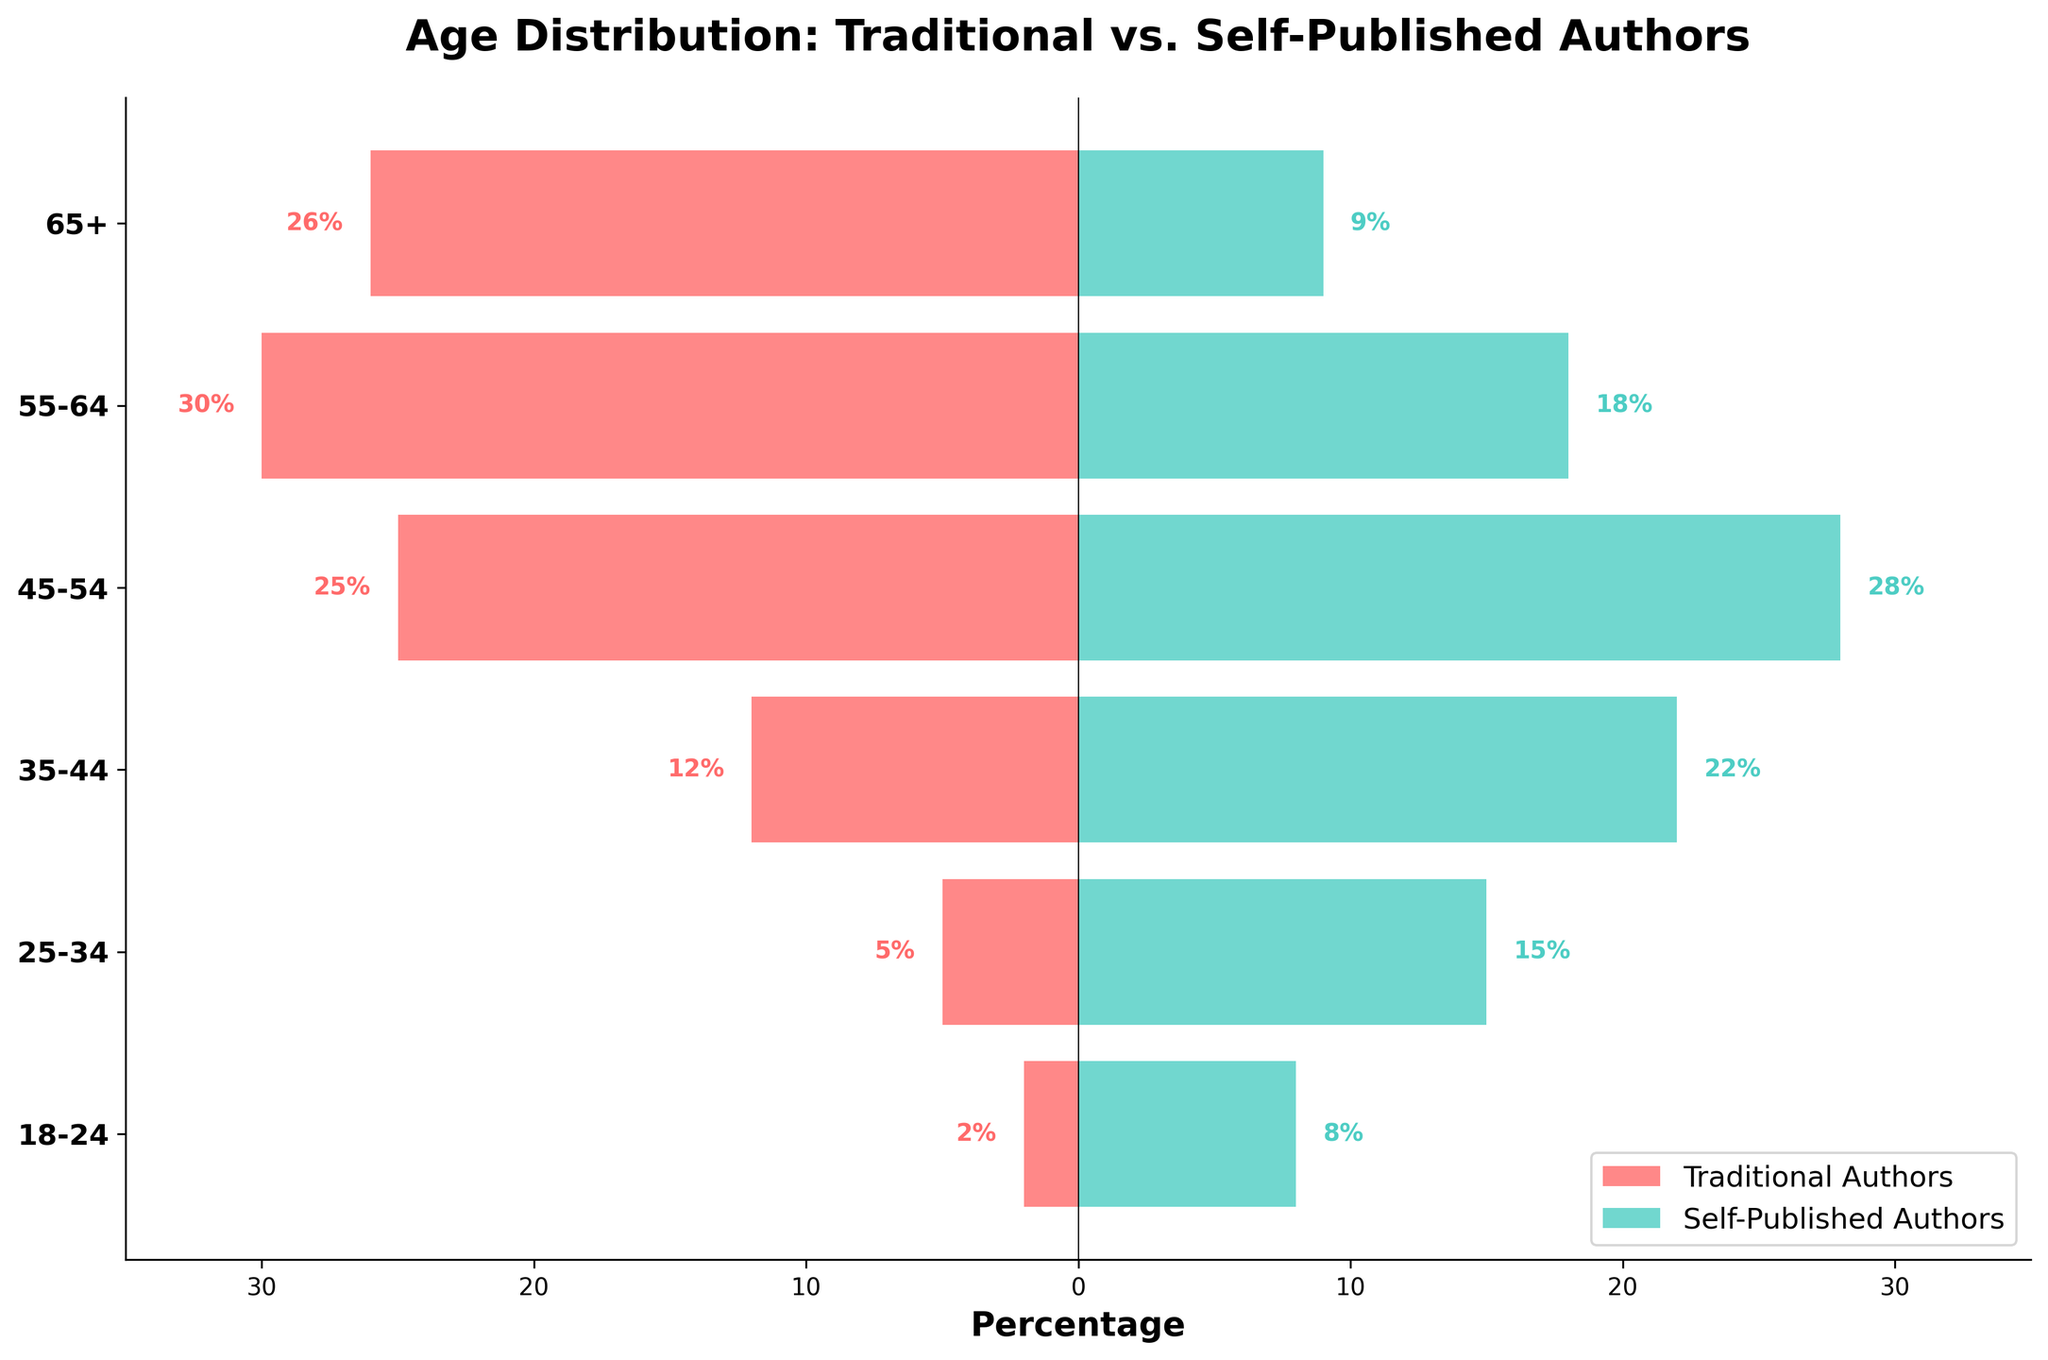What is the title of the figure? The title is usually found at the top of the figure and provides a brief description of what the figure is depicting.
Answer: Age Distribution: Traditional vs. Self-Published Authors Which age group has the highest percentage of traditional authors? The age group with the highest bar on the traditional authors' side (negative value) represents the age group with the highest percentage.
Answer: 65+ How many age groups are represented in the figure? Count the number of horizontal bars or y-tick labels to determine the total number of age groups displayed on the y-axis.
Answer: 6 What percentage of self-published authors are in the 45-54 age group? Locate the bar corresponding to the 45-54 age group on the self-published authors' side (positive value) and read the percentage label.
Answer: 28% Which age group shows a greater percentage of self-published authors than traditional authors? Compare the lengths of the bars for each age group on both sides. If the bar on the self-published authors' side is longer, then that age group has a greater percentage.
Answer: 18-24, 25-34, and 35-44 What is the combined percentage of traditional authors in the 25-34 and 35-44 age groups? Sum the percentages of traditional authors for the 25-34 and 35-44 age groups: 5% and 12%.
Answer: 17% Is the percentage of traditional authors in the 55-64 age group greater or lesser than the percentage of self-published authors in the same group? By how much? Compare the heights of the bars for the 55-64 age group. Subtract the percentage of self-published authors from the percentage of traditional authors: 30% - 18%.
Answer: Greater by 12% What is the total percentage of authors (both traditional and self-published) in the 35-44 age group? Add the percentages of traditional and self-published authors in the 35-44 age group: 12% + 22%.
Answer: 34% What is the difference in the percentage of self-published authors and traditional authors in the 18-24 age group? Subtract the percentage of traditional authors from the percentage of self-published authors in the 18-24 age group: 8% - 2%.
Answer: 6% Which age group has the closest percentage of traditional and self-published authors? Calculate the absolute difference for each age group, and the one with the smallest absolute difference indicates the closest percentage.
Answer: 45-54 